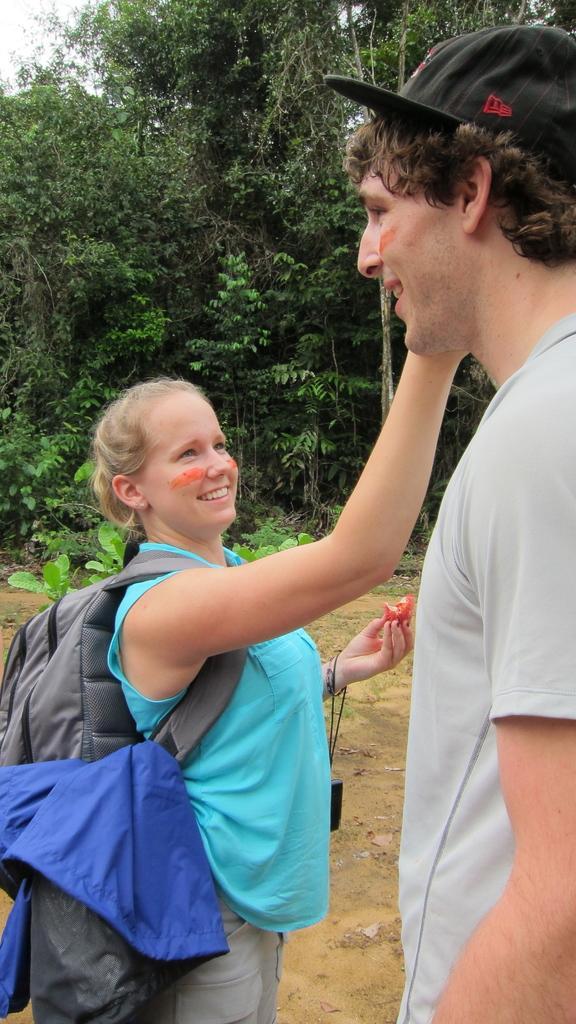Could you give a brief overview of what you see in this image? In the middle of the image two persons are standing and smiling and holding something. Behind them there are some trees. 